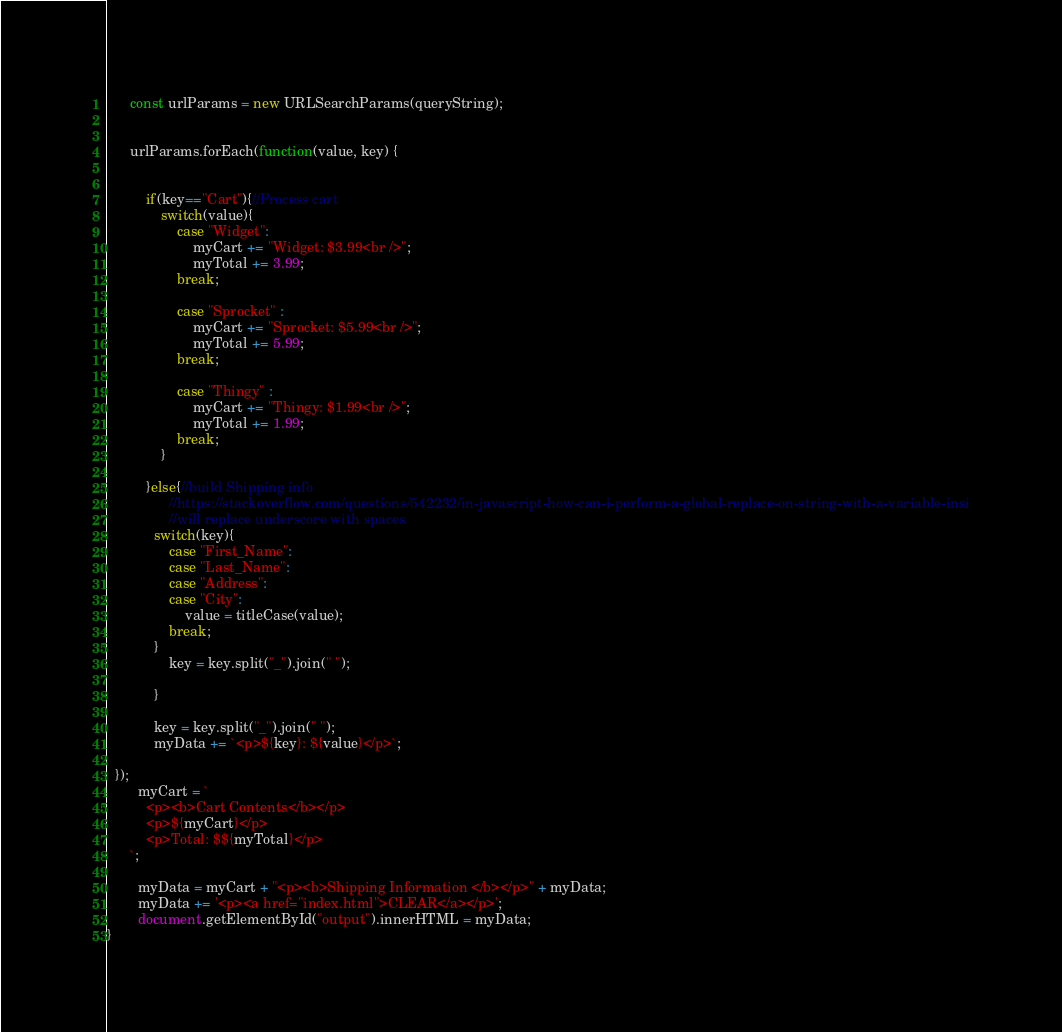<code> <loc_0><loc_0><loc_500><loc_500><_JavaScript_>      const urlParams = new URLSearchParams(queryString);
      

      urlParams.forEach(function(value, key) {

            
          if(key=="Cart"){//Process cart
              switch(value){
                  case "Widget":
                      myCart += "Widget: $3.99<br />";
                      myTotal += 3.99;
                  break;

                  case "Sprocket" :
                      myCart += "Sprocket: $5.99<br />";
                      myTotal += 5.99;
                  break;

                  case "Thingy" :
                      myCart += "Thingy: $1.99<br />";
                      myTotal += 1.99;
                  break;
              }
              
          }else{//build Shipping info
                //https://stackoverflow.com/questions/542232/in-javascript-how-can-i-perform-a-global-replace-on-string-with-a-variable-insi
                //will replace underscore with spaces
            switch(key){
                case "First_Name":
                case "Last_Name":
                case "Address":
                case "City":
                    value = titleCase(value);
                break;
            }
                key = key.split("_").join(" ");
                
            }
            
            key = key.split("_").join(" ");
            myData += `<p>${key}: ${value}</p>`;

  });
        myCart = `
          <p><b>Cart Contents</b></p>
          <p>${myCart}</p>
          <p>Total: $${myTotal}</p>
      `;

        myData = myCart + "<p><b>Shipping Information </b></p>" + myData;
        myData += '<p><a href="index.html">CLEAR</a></p>';
        document.getElementById("output").innerHTML = myData;
}

</code> 